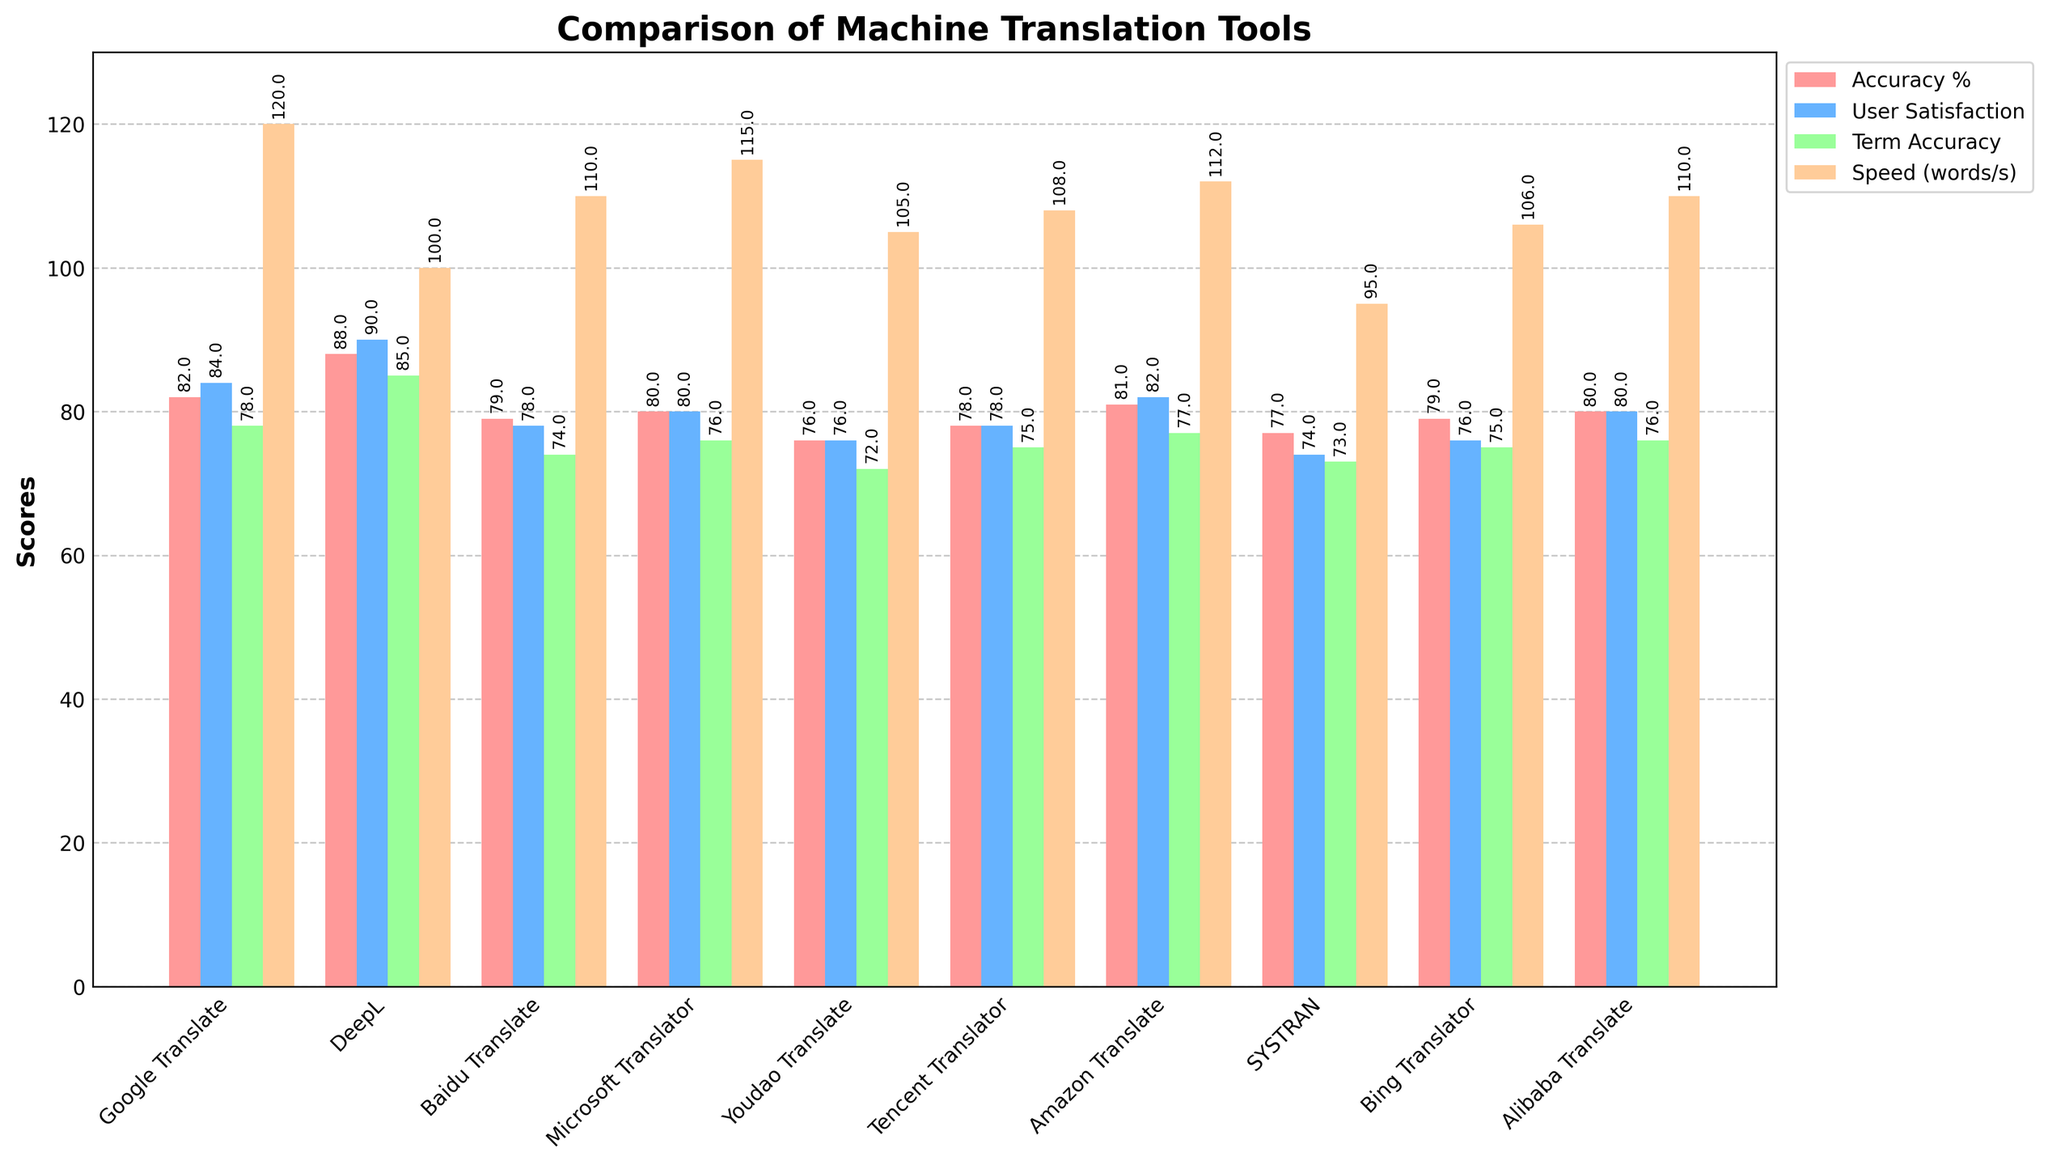Which translation tool has the highest accuracy percentage? By visually identifying the tallest red bar on the figure, we find that DeepL stands the highest, with an accuracy percentage of 88.
Answer: DeepL Which translation tool provides the best user satisfaction rating? By looking at the blue bars and comparing their heights, the highest user satisfaction rating is given to DeepL at 4.5 (multiplied by 20 on the graph).
Answer: DeepL How does the processing speed of Google Translate compare to DeepL? Google Translate's bar height in the orange color denotes 120 words/second, while DeepL’s is at 100 words/second. So, Google Translate is faster by 20 words/second.
Answer: Google Translate is faster Which tool has the lowest technical term accuracy? By comparing the heights of the green bars, we find that Youdao Translate has the lowest bar, indicating a technical term accuracy of 72.
Answer: Youdao Translate What is the combined user satisfaction rating and accuracy percentage for Microsoft Translator? Adding the user satisfaction rating (4.0*20=80) and the accuracy percentage (80) from the visual bars for Microsoft Translator gives us a total score of 160.
Answer: 160 If speed and term accuracy are equally important, which tool shows the most balanced performance between them? We need to visually compare green (term accuracy) and orange (speed) bars. Google Translate has consistent high values in both categories at 78 and 120 respectively.
Answer: Google Translate Among the tools evaluated, which provides the best balance of accuracy percentage and user satisfaction rating? Adding the multiplied user satisfaction and accuracy for each tool, DeepL stands out with an accuracy of 88 and a satisfaction rating of 4.5*20=90, summing up to 178.
Answer: DeepL Is Google Translate's term accuracy higher than its user satisfaction rating? Google Translate's term accuracy (green bar) is 78, while the user satisfaction rating (blue bar) is 4.2*20=84 from the figure. Thus, no, term accuracy is lower.
Answer: No What is the average processing speed for Microsoft Translator, Amazon Translate, and Alibaba Translate? Summing the processing speeds of Microsoft Translator (115), Amazon Translate (112), and Alibaba Translate (110) gives 337. Dividing by 3 yields 112.33.
Answer: 112.33 Which translation tool has the least improvement in user satisfaction compared to its technical term accuracy? By calculating the difference between technical term accuracy and user satisfaction for each tool, Youdao Translate has 72 (term accuracy) and 3.8*20=76 (user satisfaction), a difference of 4, the smallest improvement.
Answer: Youdao Translate 